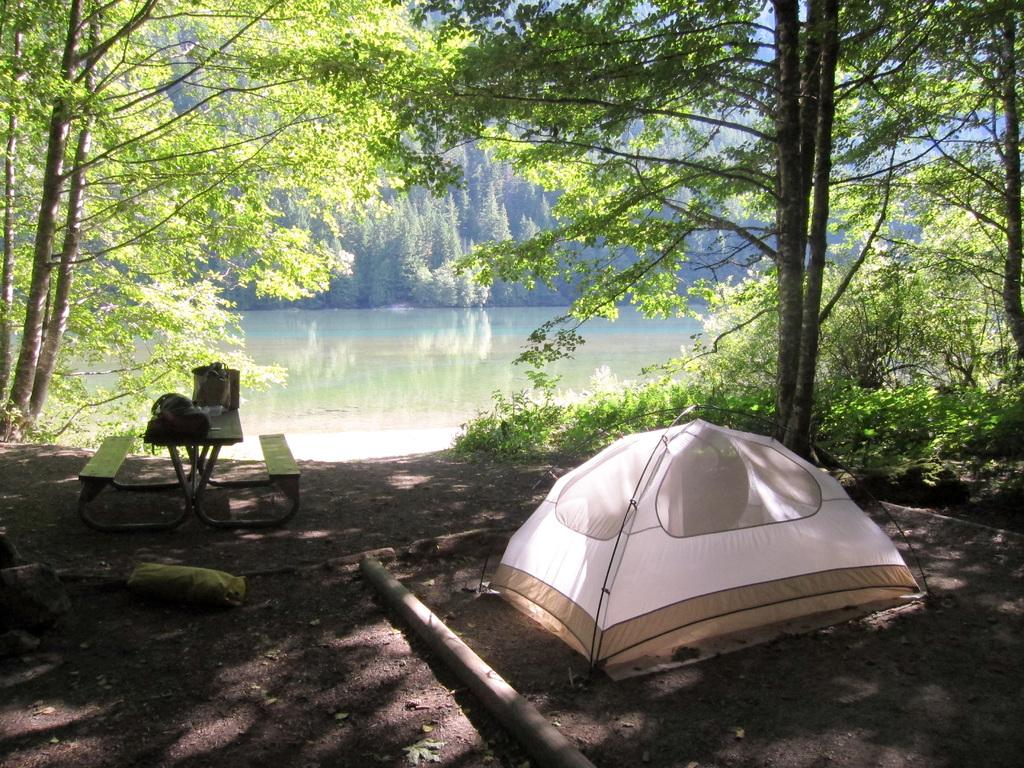What structure is present in the image? There is a tent in the image. What can be seen in the background of the image? There are trees and water visible in the background of the image. What objects are on the bench in the background of the image? There are objects on a bench in the background of the image. What type of neck can be seen on the trees in the image? There are no necks present on the trees in the image, as trees do not have necks. What force is causing the water to move in the image? There is no indication of water movement in the image, so it is not possible to determine the force causing it. 